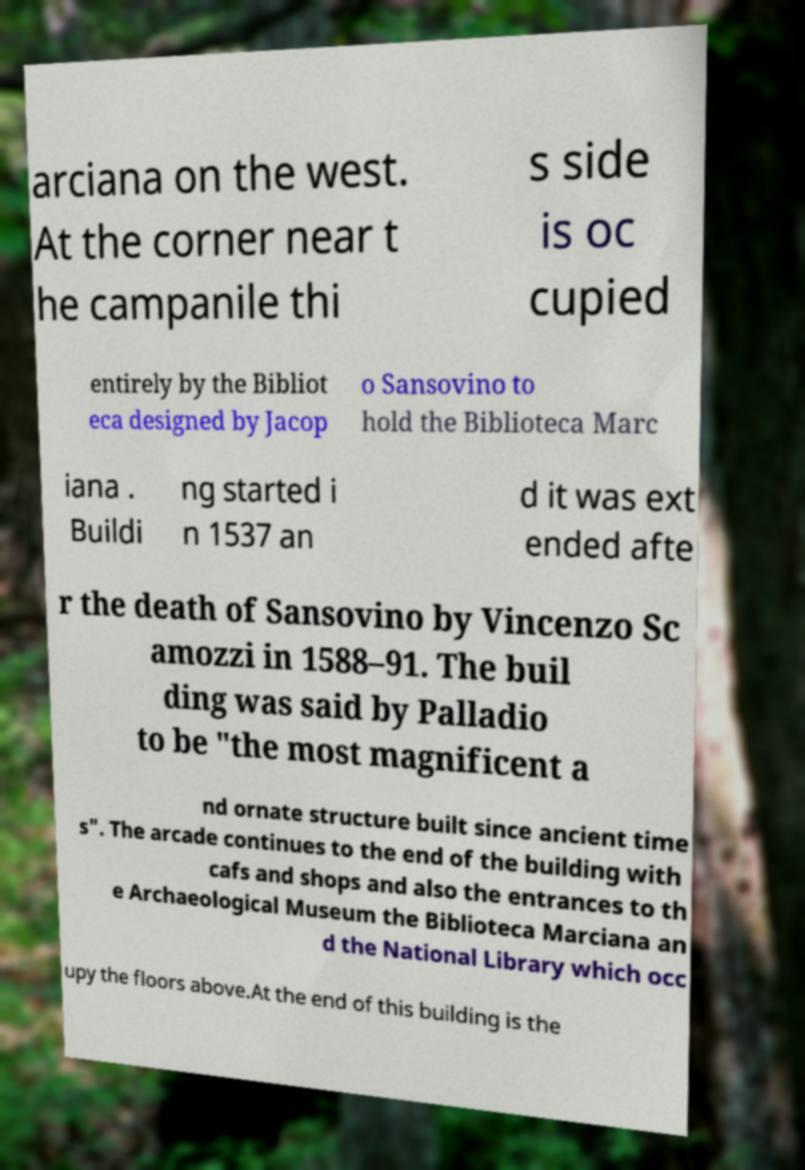For documentation purposes, I need the text within this image transcribed. Could you provide that? arciana on the west. At the corner near t he campanile thi s side is oc cupied entirely by the Bibliot eca designed by Jacop o Sansovino to hold the Biblioteca Marc iana . Buildi ng started i n 1537 an d it was ext ended afte r the death of Sansovino by Vincenzo Sc amozzi in 1588–91. The buil ding was said by Palladio to be "the most magnificent a nd ornate structure built since ancient time s". The arcade continues to the end of the building with cafs and shops and also the entrances to th e Archaeological Museum the Biblioteca Marciana an d the National Library which occ upy the floors above.At the end of this building is the 